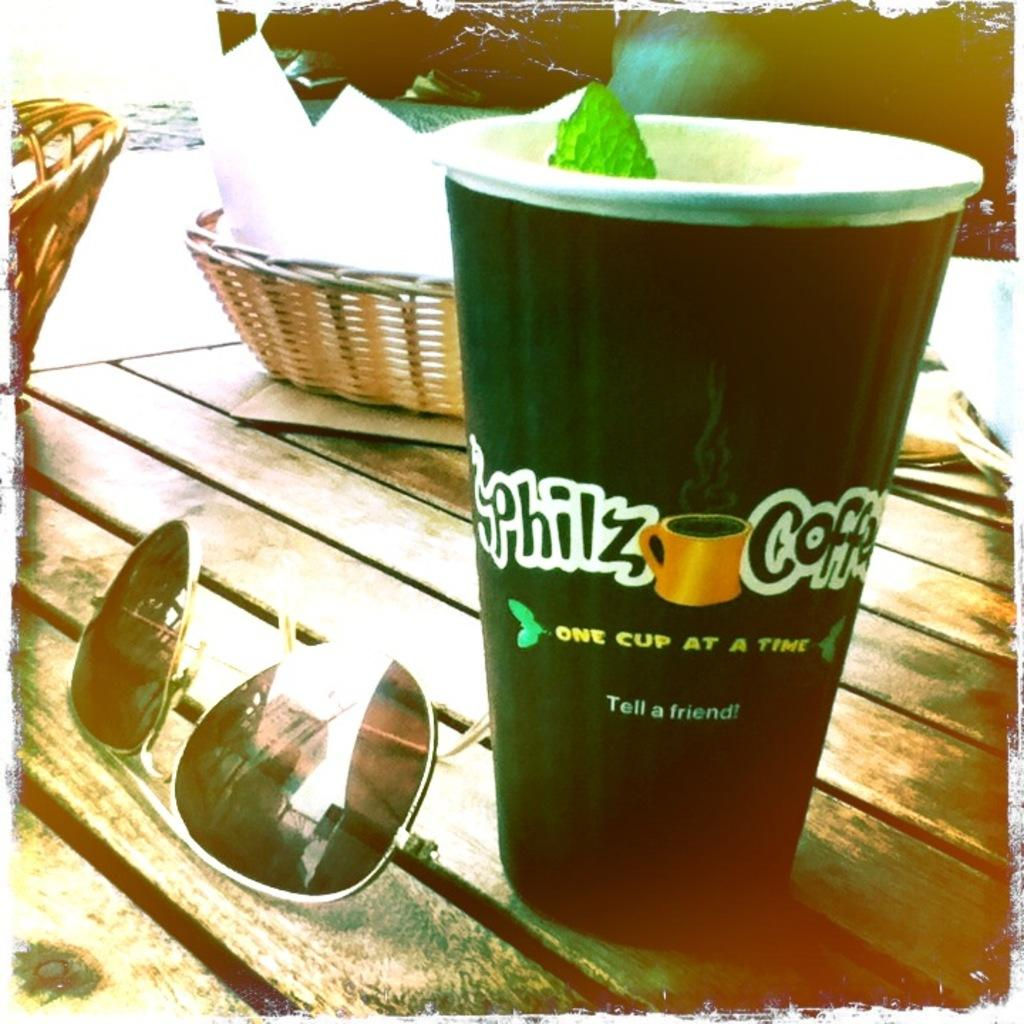What type of container is visible in the image? There is a glass in the image. What type of eyewear is present in the image? There are sunglasses in the image. How many baskets are in the image? There are two baskets in the image. Where are the objects located in the image? The objects are on a table. What type of fruit is being used to play a board game in the image? There is no board game or fruit present in the image. What type of material is the lead used for in the image? There is no lead present in the image. 